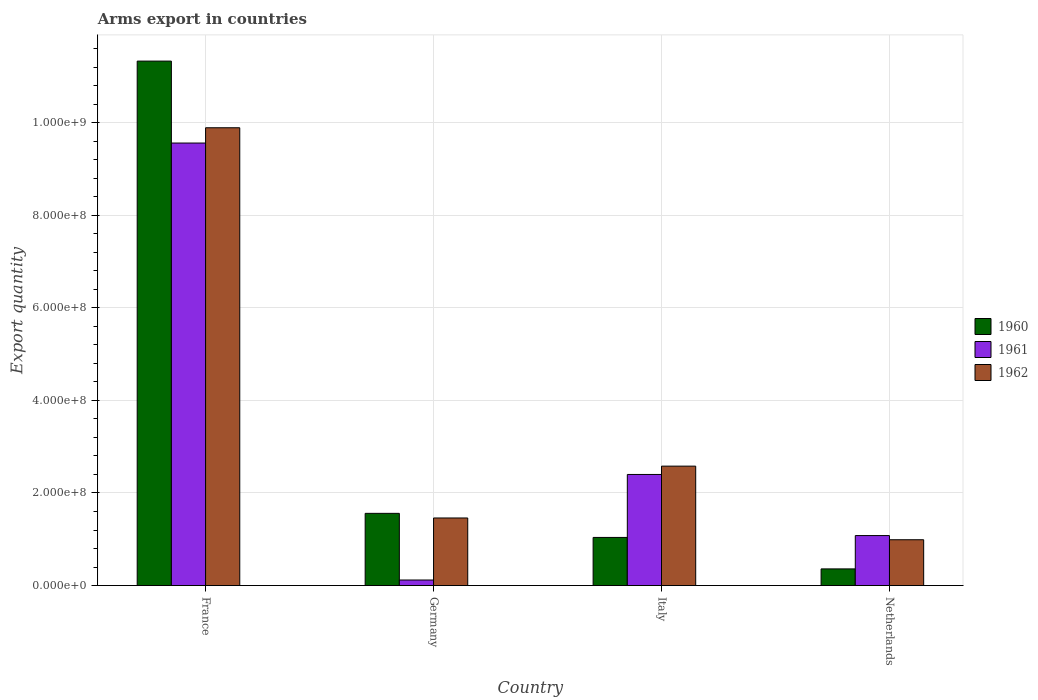Are the number of bars on each tick of the X-axis equal?
Give a very brief answer. Yes. In how many cases, is the number of bars for a given country not equal to the number of legend labels?
Keep it short and to the point. 0. What is the total arms export in 1960 in Italy?
Provide a succinct answer. 1.04e+08. Across all countries, what is the maximum total arms export in 1960?
Your answer should be compact. 1.13e+09. Across all countries, what is the minimum total arms export in 1962?
Provide a succinct answer. 9.90e+07. In which country was the total arms export in 1960 maximum?
Keep it short and to the point. France. In which country was the total arms export in 1961 minimum?
Provide a succinct answer. Germany. What is the total total arms export in 1962 in the graph?
Offer a very short reply. 1.49e+09. What is the difference between the total arms export in 1962 in France and that in Italy?
Your answer should be very brief. 7.31e+08. What is the difference between the total arms export in 1961 in France and the total arms export in 1962 in Netherlands?
Make the answer very short. 8.57e+08. What is the average total arms export in 1962 per country?
Give a very brief answer. 3.73e+08. What is the difference between the total arms export of/in 1960 and total arms export of/in 1962 in Germany?
Your answer should be very brief. 1.00e+07. What is the ratio of the total arms export in 1961 in Germany to that in Italy?
Offer a very short reply. 0.05. What is the difference between the highest and the second highest total arms export in 1962?
Offer a terse response. 8.43e+08. What is the difference between the highest and the lowest total arms export in 1962?
Your response must be concise. 8.90e+08. In how many countries, is the total arms export in 1962 greater than the average total arms export in 1962 taken over all countries?
Provide a short and direct response. 1. What does the 1st bar from the left in Netherlands represents?
Give a very brief answer. 1960. What does the 2nd bar from the right in Italy represents?
Keep it short and to the point. 1961. Is it the case that in every country, the sum of the total arms export in 1962 and total arms export in 1961 is greater than the total arms export in 1960?
Provide a succinct answer. Yes. How many bars are there?
Keep it short and to the point. 12. How many countries are there in the graph?
Make the answer very short. 4. What is the difference between two consecutive major ticks on the Y-axis?
Keep it short and to the point. 2.00e+08. Are the values on the major ticks of Y-axis written in scientific E-notation?
Your answer should be very brief. Yes. Does the graph contain any zero values?
Provide a short and direct response. No. Where does the legend appear in the graph?
Give a very brief answer. Center right. How many legend labels are there?
Ensure brevity in your answer.  3. What is the title of the graph?
Offer a very short reply. Arms export in countries. Does "2008" appear as one of the legend labels in the graph?
Your response must be concise. No. What is the label or title of the Y-axis?
Give a very brief answer. Export quantity. What is the Export quantity of 1960 in France?
Ensure brevity in your answer.  1.13e+09. What is the Export quantity of 1961 in France?
Ensure brevity in your answer.  9.56e+08. What is the Export quantity in 1962 in France?
Your response must be concise. 9.89e+08. What is the Export quantity of 1960 in Germany?
Keep it short and to the point. 1.56e+08. What is the Export quantity of 1962 in Germany?
Ensure brevity in your answer.  1.46e+08. What is the Export quantity in 1960 in Italy?
Provide a short and direct response. 1.04e+08. What is the Export quantity in 1961 in Italy?
Your answer should be very brief. 2.40e+08. What is the Export quantity of 1962 in Italy?
Ensure brevity in your answer.  2.58e+08. What is the Export quantity in 1960 in Netherlands?
Offer a terse response. 3.60e+07. What is the Export quantity in 1961 in Netherlands?
Provide a short and direct response. 1.08e+08. What is the Export quantity of 1962 in Netherlands?
Your answer should be compact. 9.90e+07. Across all countries, what is the maximum Export quantity of 1960?
Offer a terse response. 1.13e+09. Across all countries, what is the maximum Export quantity of 1961?
Provide a short and direct response. 9.56e+08. Across all countries, what is the maximum Export quantity of 1962?
Provide a succinct answer. 9.89e+08. Across all countries, what is the minimum Export quantity of 1960?
Keep it short and to the point. 3.60e+07. Across all countries, what is the minimum Export quantity of 1962?
Your answer should be compact. 9.90e+07. What is the total Export quantity of 1960 in the graph?
Make the answer very short. 1.43e+09. What is the total Export quantity of 1961 in the graph?
Your answer should be very brief. 1.32e+09. What is the total Export quantity in 1962 in the graph?
Your answer should be compact. 1.49e+09. What is the difference between the Export quantity in 1960 in France and that in Germany?
Give a very brief answer. 9.77e+08. What is the difference between the Export quantity of 1961 in France and that in Germany?
Your response must be concise. 9.44e+08. What is the difference between the Export quantity of 1962 in France and that in Germany?
Ensure brevity in your answer.  8.43e+08. What is the difference between the Export quantity in 1960 in France and that in Italy?
Give a very brief answer. 1.03e+09. What is the difference between the Export quantity in 1961 in France and that in Italy?
Offer a terse response. 7.16e+08. What is the difference between the Export quantity in 1962 in France and that in Italy?
Your answer should be compact. 7.31e+08. What is the difference between the Export quantity in 1960 in France and that in Netherlands?
Provide a short and direct response. 1.10e+09. What is the difference between the Export quantity of 1961 in France and that in Netherlands?
Keep it short and to the point. 8.48e+08. What is the difference between the Export quantity of 1962 in France and that in Netherlands?
Your response must be concise. 8.90e+08. What is the difference between the Export quantity in 1960 in Germany and that in Italy?
Give a very brief answer. 5.20e+07. What is the difference between the Export quantity in 1961 in Germany and that in Italy?
Provide a succinct answer. -2.28e+08. What is the difference between the Export quantity of 1962 in Germany and that in Italy?
Offer a very short reply. -1.12e+08. What is the difference between the Export quantity in 1960 in Germany and that in Netherlands?
Give a very brief answer. 1.20e+08. What is the difference between the Export quantity of 1961 in Germany and that in Netherlands?
Keep it short and to the point. -9.60e+07. What is the difference between the Export quantity of 1962 in Germany and that in Netherlands?
Ensure brevity in your answer.  4.70e+07. What is the difference between the Export quantity in 1960 in Italy and that in Netherlands?
Provide a short and direct response. 6.80e+07. What is the difference between the Export quantity of 1961 in Italy and that in Netherlands?
Keep it short and to the point. 1.32e+08. What is the difference between the Export quantity in 1962 in Italy and that in Netherlands?
Offer a very short reply. 1.59e+08. What is the difference between the Export quantity of 1960 in France and the Export quantity of 1961 in Germany?
Give a very brief answer. 1.12e+09. What is the difference between the Export quantity of 1960 in France and the Export quantity of 1962 in Germany?
Your response must be concise. 9.87e+08. What is the difference between the Export quantity of 1961 in France and the Export quantity of 1962 in Germany?
Offer a terse response. 8.10e+08. What is the difference between the Export quantity in 1960 in France and the Export quantity in 1961 in Italy?
Your answer should be very brief. 8.93e+08. What is the difference between the Export quantity in 1960 in France and the Export quantity in 1962 in Italy?
Give a very brief answer. 8.75e+08. What is the difference between the Export quantity in 1961 in France and the Export quantity in 1962 in Italy?
Give a very brief answer. 6.98e+08. What is the difference between the Export quantity of 1960 in France and the Export quantity of 1961 in Netherlands?
Make the answer very short. 1.02e+09. What is the difference between the Export quantity in 1960 in France and the Export quantity in 1962 in Netherlands?
Provide a short and direct response. 1.03e+09. What is the difference between the Export quantity of 1961 in France and the Export quantity of 1962 in Netherlands?
Your answer should be compact. 8.57e+08. What is the difference between the Export quantity of 1960 in Germany and the Export quantity of 1961 in Italy?
Offer a terse response. -8.40e+07. What is the difference between the Export quantity of 1960 in Germany and the Export quantity of 1962 in Italy?
Provide a short and direct response. -1.02e+08. What is the difference between the Export quantity in 1961 in Germany and the Export quantity in 1962 in Italy?
Offer a very short reply. -2.46e+08. What is the difference between the Export quantity in 1960 in Germany and the Export quantity in 1961 in Netherlands?
Offer a terse response. 4.80e+07. What is the difference between the Export quantity of 1960 in Germany and the Export quantity of 1962 in Netherlands?
Your answer should be compact. 5.70e+07. What is the difference between the Export quantity in 1961 in Germany and the Export quantity in 1962 in Netherlands?
Ensure brevity in your answer.  -8.70e+07. What is the difference between the Export quantity of 1961 in Italy and the Export quantity of 1962 in Netherlands?
Provide a succinct answer. 1.41e+08. What is the average Export quantity in 1960 per country?
Your answer should be compact. 3.57e+08. What is the average Export quantity in 1961 per country?
Offer a terse response. 3.29e+08. What is the average Export quantity in 1962 per country?
Offer a terse response. 3.73e+08. What is the difference between the Export quantity of 1960 and Export quantity of 1961 in France?
Your answer should be very brief. 1.77e+08. What is the difference between the Export quantity of 1960 and Export quantity of 1962 in France?
Your response must be concise. 1.44e+08. What is the difference between the Export quantity of 1961 and Export quantity of 1962 in France?
Your answer should be very brief. -3.30e+07. What is the difference between the Export quantity in 1960 and Export quantity in 1961 in Germany?
Offer a very short reply. 1.44e+08. What is the difference between the Export quantity of 1961 and Export quantity of 1962 in Germany?
Offer a terse response. -1.34e+08. What is the difference between the Export quantity in 1960 and Export quantity in 1961 in Italy?
Your answer should be compact. -1.36e+08. What is the difference between the Export quantity in 1960 and Export quantity in 1962 in Italy?
Your answer should be very brief. -1.54e+08. What is the difference between the Export quantity of 1961 and Export quantity of 1962 in Italy?
Ensure brevity in your answer.  -1.80e+07. What is the difference between the Export quantity in 1960 and Export quantity in 1961 in Netherlands?
Offer a very short reply. -7.20e+07. What is the difference between the Export quantity in 1960 and Export quantity in 1962 in Netherlands?
Your response must be concise. -6.30e+07. What is the difference between the Export quantity of 1961 and Export quantity of 1962 in Netherlands?
Your answer should be very brief. 9.00e+06. What is the ratio of the Export quantity in 1960 in France to that in Germany?
Make the answer very short. 7.26. What is the ratio of the Export quantity in 1961 in France to that in Germany?
Provide a short and direct response. 79.67. What is the ratio of the Export quantity of 1962 in France to that in Germany?
Keep it short and to the point. 6.77. What is the ratio of the Export quantity in 1960 in France to that in Italy?
Ensure brevity in your answer.  10.89. What is the ratio of the Export quantity in 1961 in France to that in Italy?
Give a very brief answer. 3.98. What is the ratio of the Export quantity of 1962 in France to that in Italy?
Provide a short and direct response. 3.83. What is the ratio of the Export quantity of 1960 in France to that in Netherlands?
Provide a short and direct response. 31.47. What is the ratio of the Export quantity in 1961 in France to that in Netherlands?
Your response must be concise. 8.85. What is the ratio of the Export quantity of 1962 in France to that in Netherlands?
Offer a very short reply. 9.99. What is the ratio of the Export quantity in 1960 in Germany to that in Italy?
Give a very brief answer. 1.5. What is the ratio of the Export quantity of 1962 in Germany to that in Italy?
Provide a short and direct response. 0.57. What is the ratio of the Export quantity of 1960 in Germany to that in Netherlands?
Offer a terse response. 4.33. What is the ratio of the Export quantity of 1961 in Germany to that in Netherlands?
Your response must be concise. 0.11. What is the ratio of the Export quantity in 1962 in Germany to that in Netherlands?
Your answer should be compact. 1.47. What is the ratio of the Export quantity in 1960 in Italy to that in Netherlands?
Ensure brevity in your answer.  2.89. What is the ratio of the Export quantity of 1961 in Italy to that in Netherlands?
Your answer should be very brief. 2.22. What is the ratio of the Export quantity in 1962 in Italy to that in Netherlands?
Your answer should be very brief. 2.61. What is the difference between the highest and the second highest Export quantity of 1960?
Make the answer very short. 9.77e+08. What is the difference between the highest and the second highest Export quantity of 1961?
Offer a very short reply. 7.16e+08. What is the difference between the highest and the second highest Export quantity of 1962?
Ensure brevity in your answer.  7.31e+08. What is the difference between the highest and the lowest Export quantity in 1960?
Make the answer very short. 1.10e+09. What is the difference between the highest and the lowest Export quantity in 1961?
Your response must be concise. 9.44e+08. What is the difference between the highest and the lowest Export quantity of 1962?
Provide a succinct answer. 8.90e+08. 